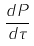<formula> <loc_0><loc_0><loc_500><loc_500>\frac { d P } { d \tau }</formula> 